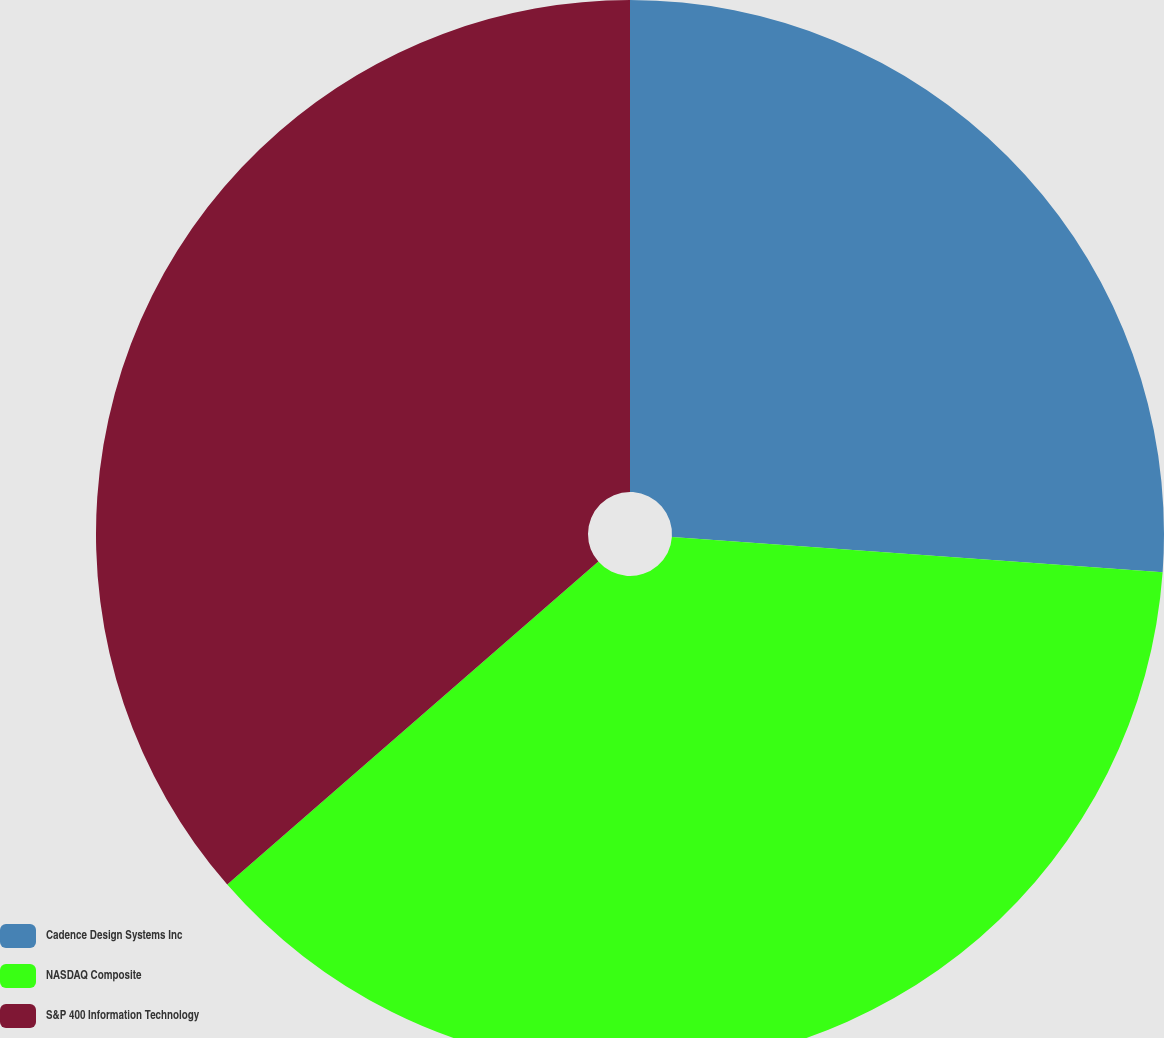Convert chart to OTSL. <chart><loc_0><loc_0><loc_500><loc_500><pie_chart><fcel>Cadence Design Systems Inc<fcel>NASDAQ Composite<fcel>S&P 400 Information Technology<nl><fcel>26.14%<fcel>37.46%<fcel>36.4%<nl></chart> 